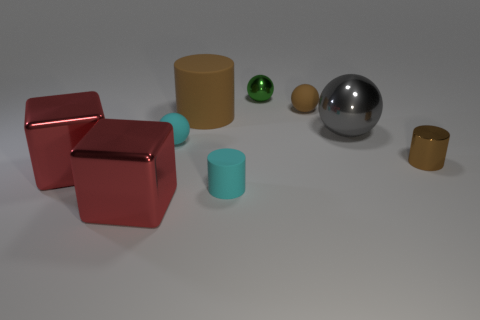How many purple things are small balls or rubber objects?
Your response must be concise. 0. There is a brown cylinder that is behind the tiny brown metallic object; is it the same size as the metallic sphere in front of the green thing?
Give a very brief answer. Yes. How many objects are green objects or small rubber things?
Your response must be concise. 4. Is there a purple thing that has the same shape as the small green object?
Give a very brief answer. No. Is the number of red blocks less than the number of large metallic balls?
Your response must be concise. No. Do the small brown metal thing and the green metallic thing have the same shape?
Offer a terse response. No. How many things are rubber spheres or cylinders that are right of the tiny rubber cylinder?
Your response must be concise. 3. What number of red things are there?
Your answer should be compact. 2. Is there a gray object of the same size as the brown shiny cylinder?
Your answer should be compact. No. Are there fewer large brown things on the left side of the big matte cylinder than gray rubber things?
Give a very brief answer. No. 